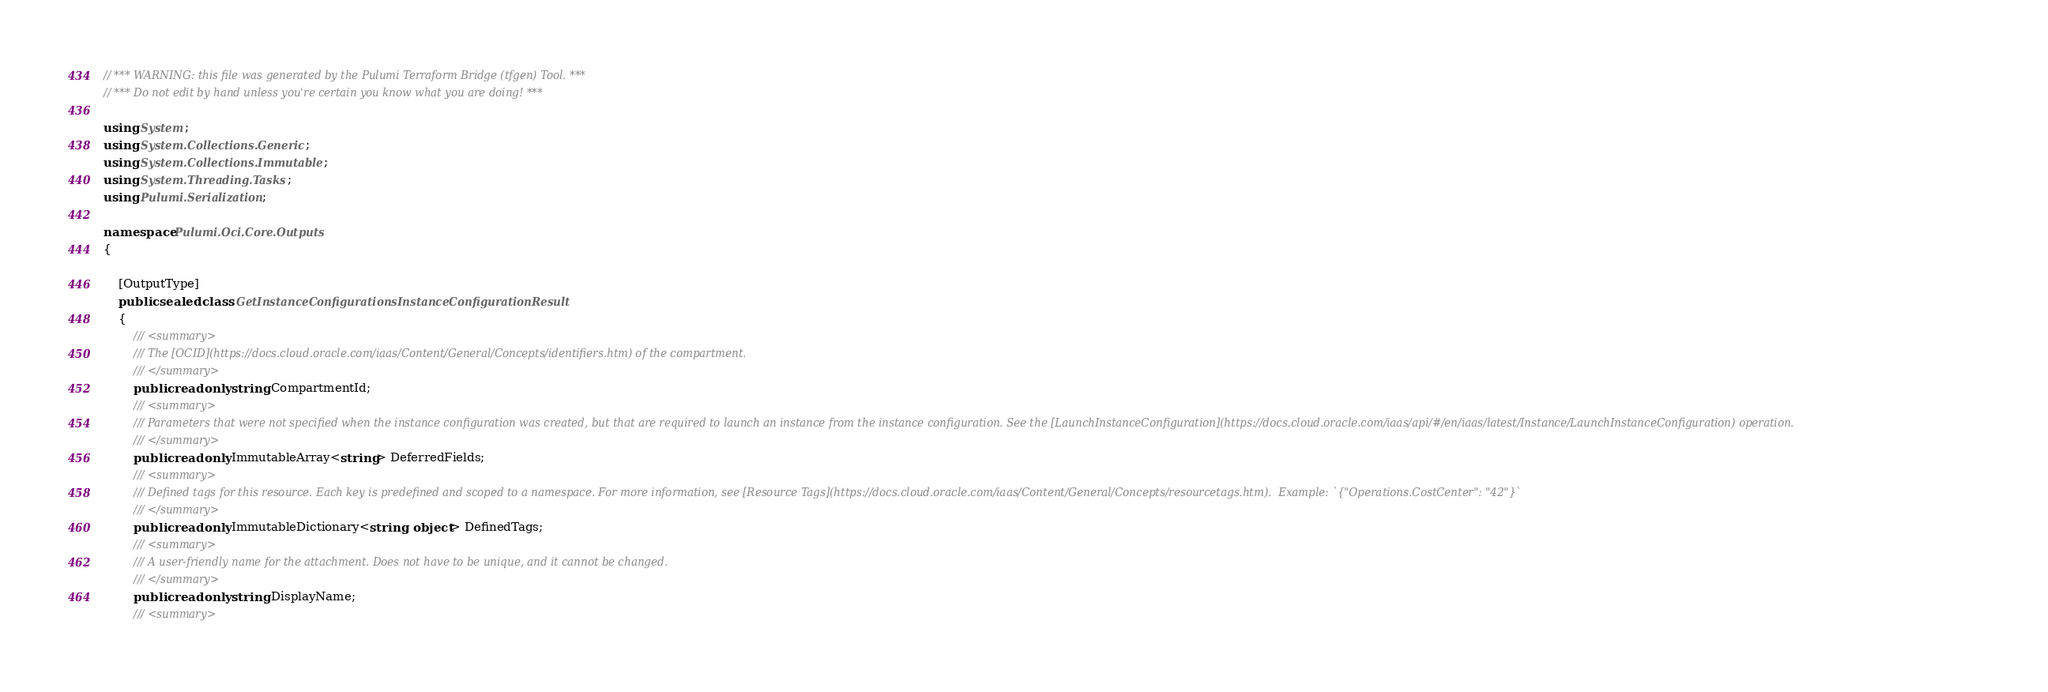<code> <loc_0><loc_0><loc_500><loc_500><_C#_>// *** WARNING: this file was generated by the Pulumi Terraform Bridge (tfgen) Tool. ***
// *** Do not edit by hand unless you're certain you know what you are doing! ***

using System;
using System.Collections.Generic;
using System.Collections.Immutable;
using System.Threading.Tasks;
using Pulumi.Serialization;

namespace Pulumi.Oci.Core.Outputs
{

    [OutputType]
    public sealed class GetInstanceConfigurationsInstanceConfigurationResult
    {
        /// <summary>
        /// The [OCID](https://docs.cloud.oracle.com/iaas/Content/General/Concepts/identifiers.htm) of the compartment.
        /// </summary>
        public readonly string CompartmentId;
        /// <summary>
        /// Parameters that were not specified when the instance configuration was created, but that are required to launch an instance from the instance configuration. See the [LaunchInstanceConfiguration](https://docs.cloud.oracle.com/iaas/api/#/en/iaas/latest/Instance/LaunchInstanceConfiguration) operation.
        /// </summary>
        public readonly ImmutableArray<string> DeferredFields;
        /// <summary>
        /// Defined tags for this resource. Each key is predefined and scoped to a namespace. For more information, see [Resource Tags](https://docs.cloud.oracle.com/iaas/Content/General/Concepts/resourcetags.htm).  Example: `{"Operations.CostCenter": "42"}`
        /// </summary>
        public readonly ImmutableDictionary<string, object> DefinedTags;
        /// <summary>
        /// A user-friendly name for the attachment. Does not have to be unique, and it cannot be changed.
        /// </summary>
        public readonly string DisplayName;
        /// <summary></code> 